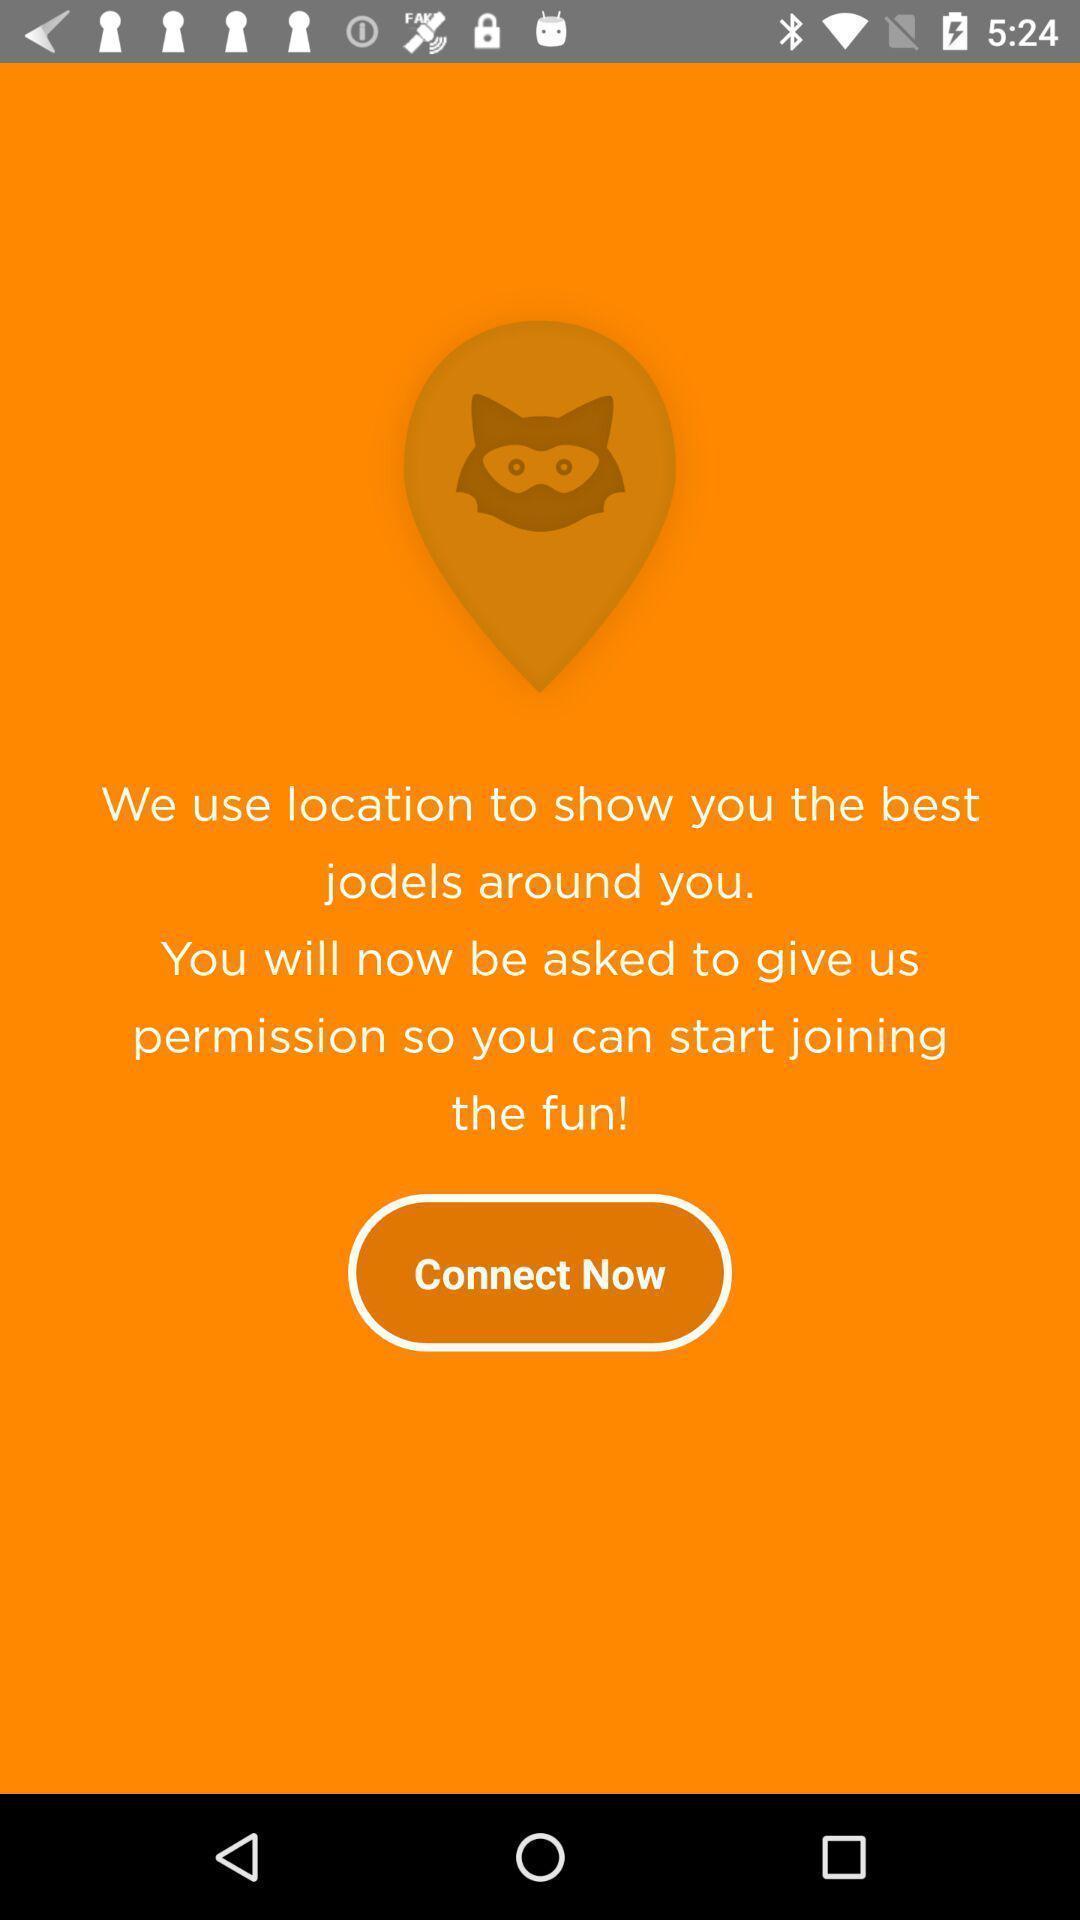Explain what's happening in this screen capture. Page showing a connect now button. 